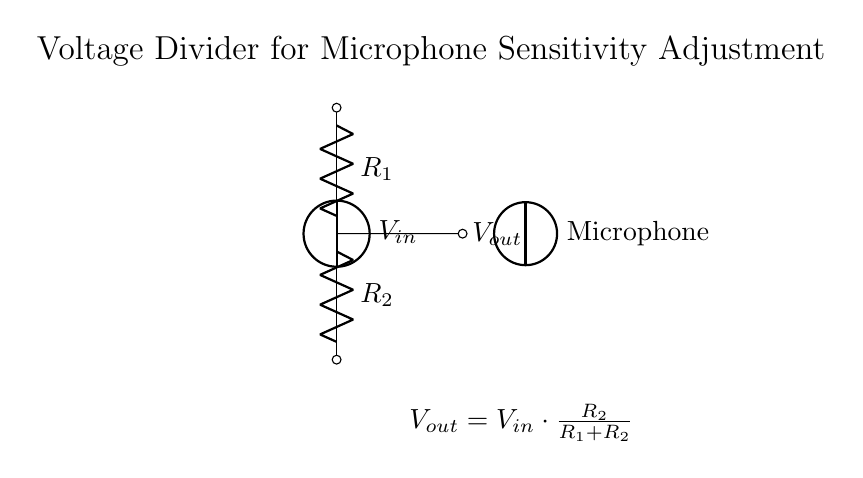What is the voltage source in this circuit? The voltage source, labeled as V_in, is the component that provides the input voltage for the voltage divider. It typically supplies the power needed for the circuit to operate.
Answer: V_in What are the two resistors in the circuit? The two resistors are labeled R_1 and R_2. They are used to create the voltage division necessary for adjusting sensitivity.
Answer: R_1 and R_2 What is the output voltage formula in this circuit? The output voltage, V_out, is given by the formula V_out = V_in * (R_2 / (R_1 + R_2)), which helps determine the voltage available to the microphone based on the resistor values.
Answer: V_out = V_in * (R_2 / (R_1 + R_2)) If R_1 is twice the value of R_2, what is the ratio of V_out to V_in? When R_1 is double the value of R_2, the formula simplifies to V_out = V_in * (1/3). This shows that the output voltage will be one-third of the input voltage.
Answer: One-third Why is this circuit designed as a voltage divider for a microphone? A voltage divider is used for microphones to adjust the voltage levels appropriately for sound capturing, ensuring the output does not saturate or clip the sound signals received, providing optimum sensitivity.
Answer: To adjust microphone sensitivity What happens to V_out if R_2 is decreased while R_1 remains constant? If R_2 is decreased and R_1 remains constant, the fraction R_2 / (R_1 + R_2) will decrease, resulting in a lower output voltage V_out.
Answer: V_out decreases 